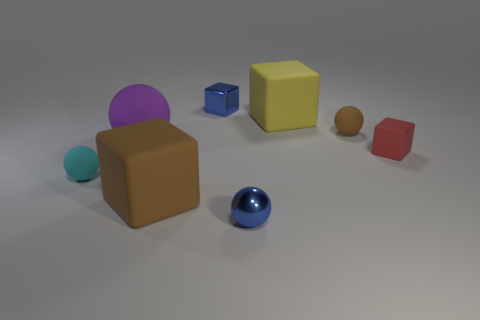What number of other objects are the same material as the tiny red thing?
Your response must be concise. 5. There is a rubber thing that is in front of the cyan matte ball; how big is it?
Offer a terse response. Large. What number of small rubber things are on the right side of the large brown rubber cube and left of the red rubber block?
Provide a short and direct response. 1. What material is the tiny object left of the metallic thing behind the small cyan matte thing?
Your answer should be very brief. Rubber. What material is the cyan object that is the same shape as the purple rubber object?
Offer a terse response. Rubber. Is there a tiny yellow ball?
Make the answer very short. No. What shape is the blue object that is the same material as the blue cube?
Your response must be concise. Sphere. What material is the cube that is in front of the cyan matte thing?
Give a very brief answer. Rubber. There is a matte ball that is in front of the purple object; is its color the same as the big sphere?
Ensure brevity in your answer.  No. What size is the purple rubber ball that is behind the brown thing in front of the small brown thing?
Make the answer very short. Large. 